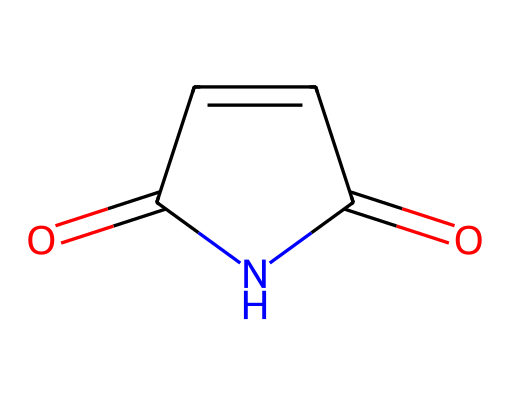What is the molecular formula of maleimide? To determine the molecular formula from the SMILES representation, first identify the atoms represented: there are two carbonyl (C=O) groups and a five-membered ring of carbon and nitrogen. Counting the elements gives: C (4), H (3), N (1), O (2). The combined formula is C4H3N1O2.
Answer: C4H3NO2 How many carbon atoms are present in maleimide? By examining the SMILES notation, the number of carbon atoms (C) can be counted, which are four in total present in the structure.
Answer: 4 What type of functional groups are present in maleimide? The structure contains carbonyl (C=O) and imide (C-N) functional groups. Carbonyl groups are indicated by the double bonds with oxygen, and the presence of nitrogen in the ring identifies it as an imide.
Answer: carbonyl and imide What is the total number of rings in maleimide? The structure shows a single five-membered ring consisting of two carbonyl groups and one nitrogen atom, making it one ring in total.
Answer: 1 What is the significance of the nitrogen in maleimide? The nitrogen atom plays a crucial role in defining the compound as an imide; it connects two carbonyl groups and influences the chemical reactivity of the molecule. The nitrogen's presence distinguishes this compound from other classes of carbonyls.
Answer: defines it as an imide Why is maleimide used in polymer-based coatings? Maleimide is used due to its robust chemical structure and ability to react with various polymers, leading to improved durability and adhesion in coating applications. Its imide nature offers thermal stability important for building materials.
Answer: thermal stability and adhesion 